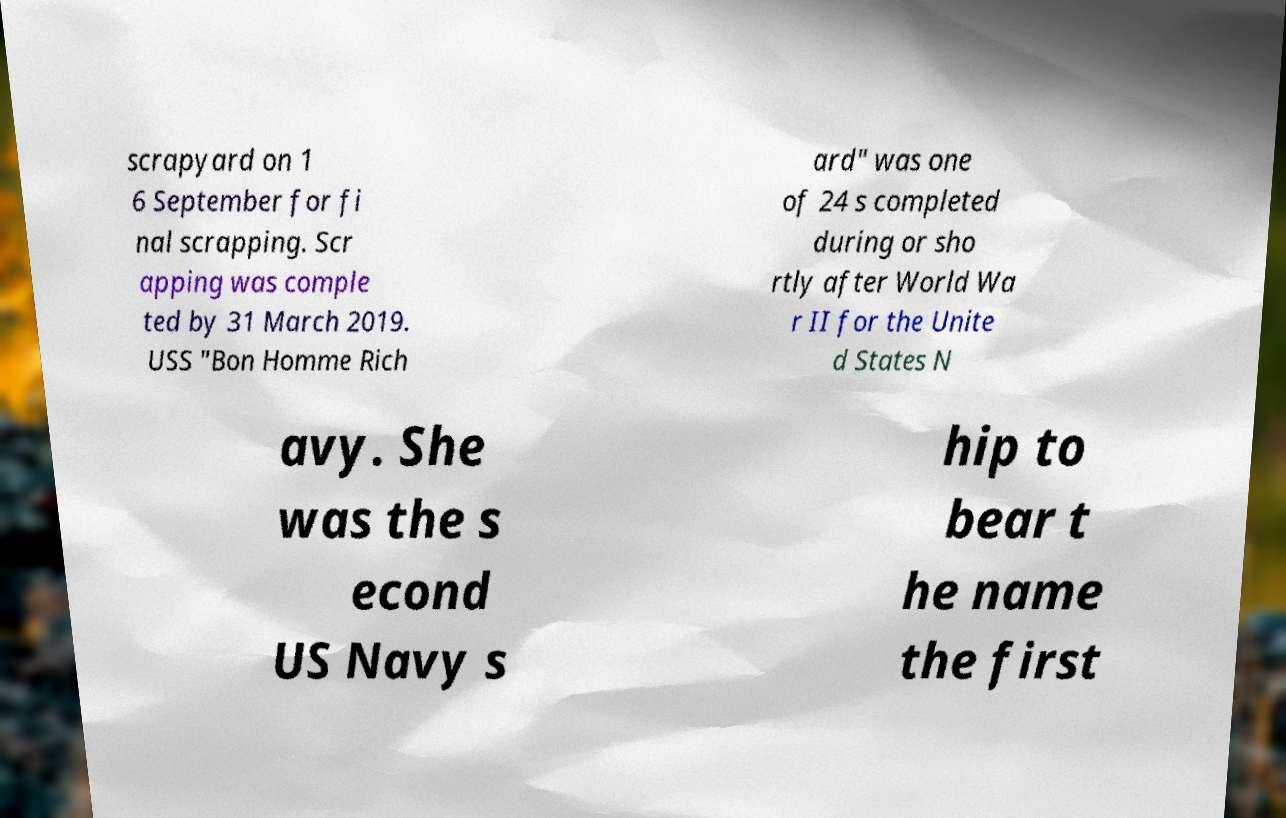What messages or text are displayed in this image? I need them in a readable, typed format. scrapyard on 1 6 September for fi nal scrapping. Scr apping was comple ted by 31 March 2019. USS "Bon Homme Rich ard" was one of 24 s completed during or sho rtly after World Wa r II for the Unite d States N avy. She was the s econd US Navy s hip to bear t he name the first 